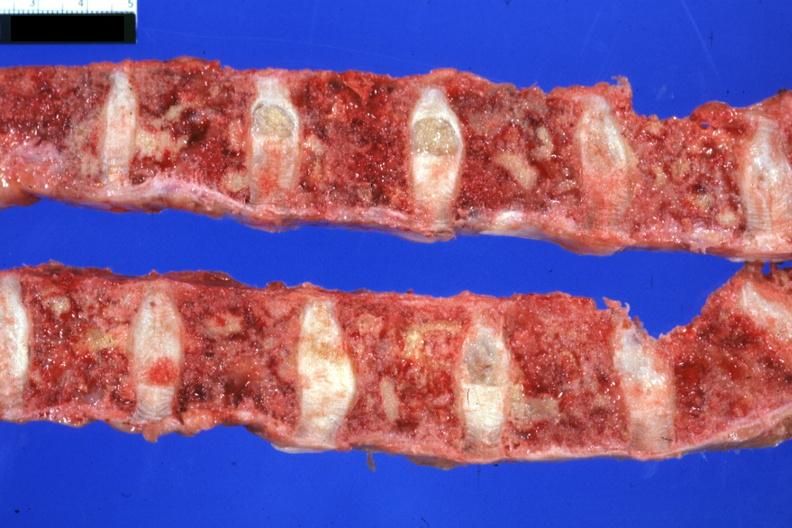how is excellent lesions sigmoid colon papillary adenocarcinoma 6mo post colon resection with complications?
Answer the question using a single word or phrase. Multiple 